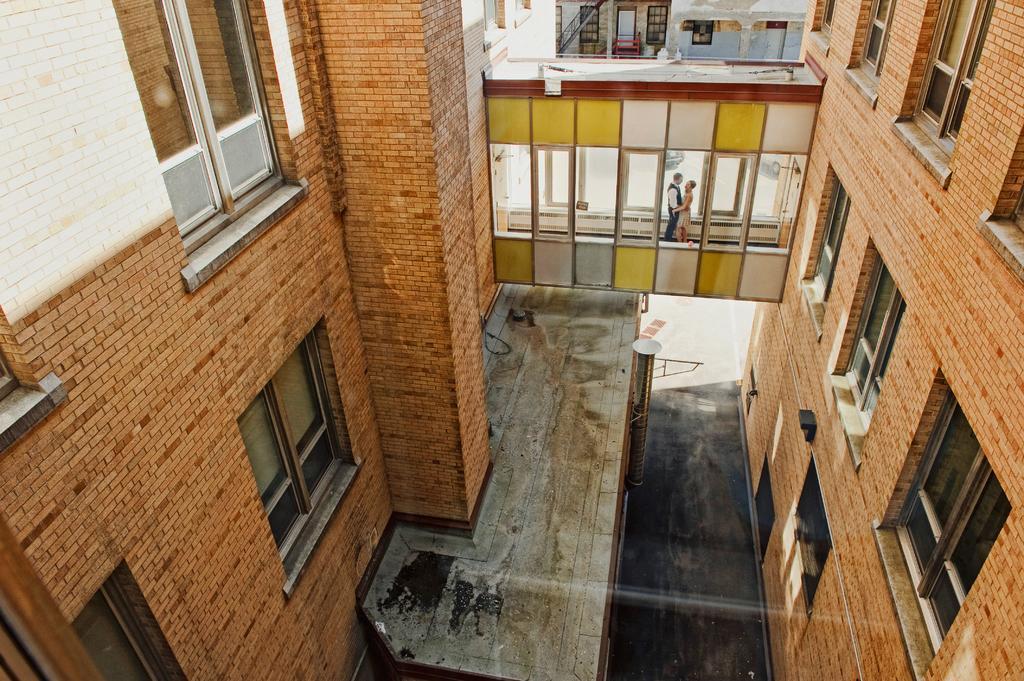Describe this image in one or two sentences. In this image I can see a building which is brown in color, few windows of the building, a bridge and few persons on the bridge. In the background I can see another building. 